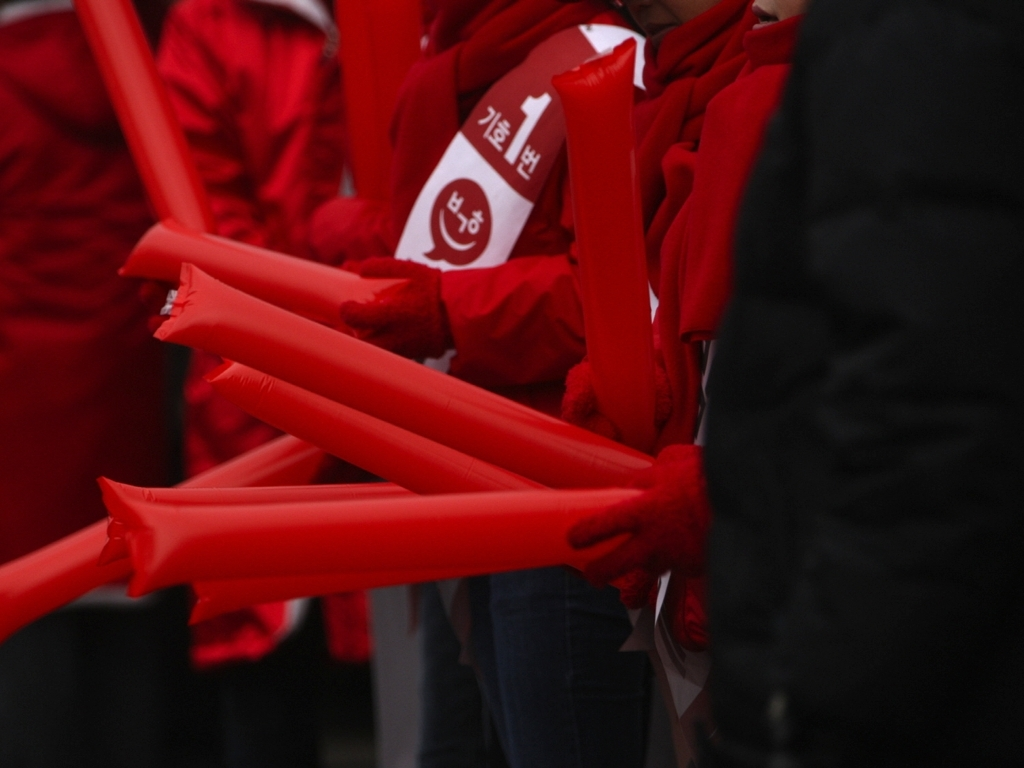Is there noticeable noise in the image? The image appears to have a low level of noise, maintaining a fairly clear quality. The focus seems to be on the red objects, which could indicate the photo was taken in low light or with a high ISO setting, often resulting in some graininess, but in this case, the noise is not significantly detracting from the image's clarity. 